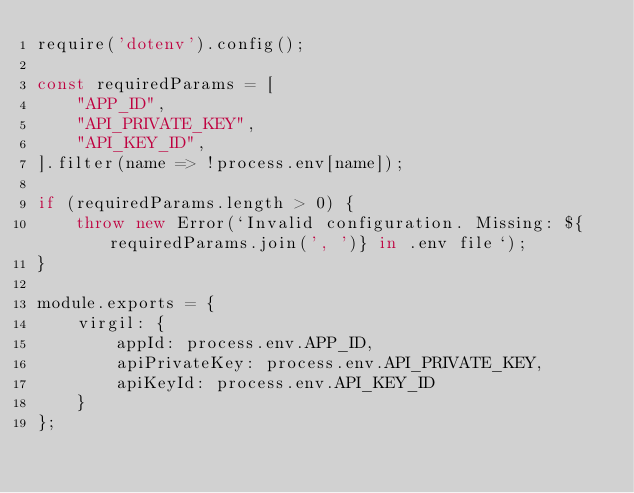<code> <loc_0><loc_0><loc_500><loc_500><_JavaScript_>require('dotenv').config();

const requiredParams = [
    "APP_ID",
    "API_PRIVATE_KEY",
    "API_KEY_ID",
].filter(name => !process.env[name]);

if (requiredParams.length > 0) {
    throw new Error(`Invalid configuration. Missing: ${requiredParams.join(', ')} in .env file`);
}

module.exports = {
    virgil: {
        appId: process.env.APP_ID,
        apiPrivateKey: process.env.API_PRIVATE_KEY,
        apiKeyId: process.env.API_KEY_ID
    }
};</code> 